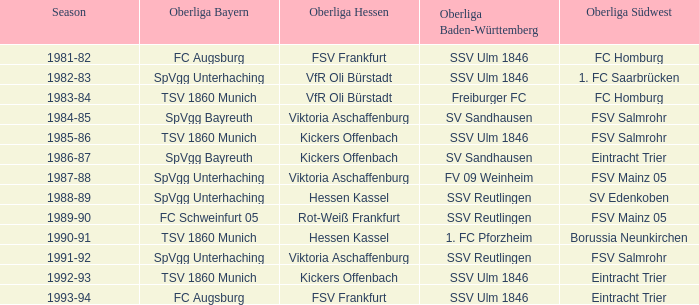Which oberliga baden-württemberg possesses a 1991-92 duration? SSV Reutlingen. 